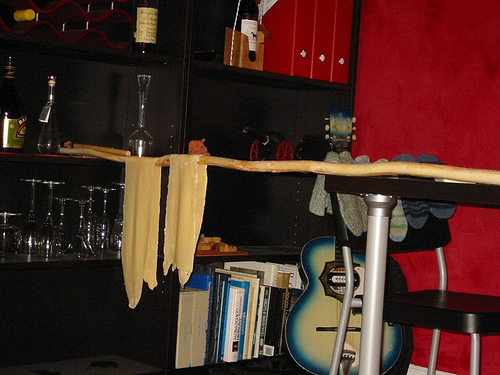<image>
Can you confirm if the guitar is on the shelf? No. The guitar is not positioned on the shelf. They may be near each other, but the guitar is not supported by or resting on top of the shelf. 